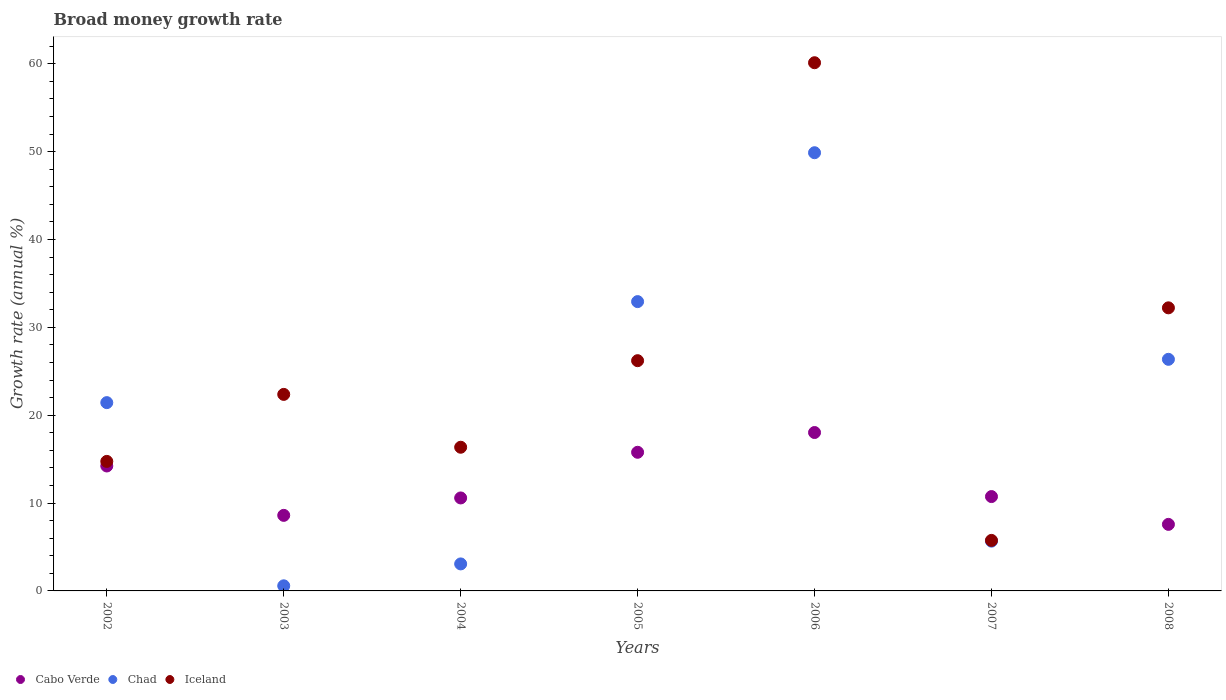What is the growth rate in Cabo Verde in 2005?
Offer a terse response. 15.78. Across all years, what is the maximum growth rate in Iceland?
Make the answer very short. 60.12. Across all years, what is the minimum growth rate in Cabo Verde?
Offer a terse response. 7.57. What is the total growth rate in Chad in the graph?
Make the answer very short. 139.92. What is the difference between the growth rate in Chad in 2003 and that in 2007?
Your response must be concise. -5.08. What is the difference between the growth rate in Iceland in 2006 and the growth rate in Chad in 2003?
Give a very brief answer. 59.54. What is the average growth rate in Iceland per year?
Give a very brief answer. 25.39. In the year 2005, what is the difference between the growth rate in Iceland and growth rate in Chad?
Your answer should be compact. -6.72. What is the ratio of the growth rate in Iceland in 2003 to that in 2006?
Your response must be concise. 0.37. What is the difference between the highest and the second highest growth rate in Iceland?
Provide a short and direct response. 27.9. What is the difference between the highest and the lowest growth rate in Iceland?
Your response must be concise. 54.37. In how many years, is the growth rate in Chad greater than the average growth rate in Chad taken over all years?
Your response must be concise. 4. Is the sum of the growth rate in Cabo Verde in 2002 and 2006 greater than the maximum growth rate in Chad across all years?
Ensure brevity in your answer.  No. Does the growth rate in Iceland monotonically increase over the years?
Offer a very short reply. No. How many years are there in the graph?
Provide a succinct answer. 7. What is the difference between two consecutive major ticks on the Y-axis?
Your answer should be very brief. 10. Are the values on the major ticks of Y-axis written in scientific E-notation?
Your response must be concise. No. Does the graph contain any zero values?
Your answer should be very brief. No. How many legend labels are there?
Give a very brief answer. 3. What is the title of the graph?
Offer a terse response. Broad money growth rate. What is the label or title of the Y-axis?
Your response must be concise. Growth rate (annual %). What is the Growth rate (annual %) in Cabo Verde in 2002?
Offer a very short reply. 14.22. What is the Growth rate (annual %) in Chad in 2002?
Your answer should be very brief. 21.43. What is the Growth rate (annual %) in Iceland in 2002?
Keep it short and to the point. 14.74. What is the Growth rate (annual %) of Cabo Verde in 2003?
Offer a terse response. 8.6. What is the Growth rate (annual %) in Chad in 2003?
Provide a succinct answer. 0.58. What is the Growth rate (annual %) in Iceland in 2003?
Make the answer very short. 22.37. What is the Growth rate (annual %) of Cabo Verde in 2004?
Keep it short and to the point. 10.58. What is the Growth rate (annual %) of Chad in 2004?
Your answer should be very brief. 3.07. What is the Growth rate (annual %) of Iceland in 2004?
Provide a succinct answer. 16.35. What is the Growth rate (annual %) in Cabo Verde in 2005?
Offer a very short reply. 15.78. What is the Growth rate (annual %) of Chad in 2005?
Offer a terse response. 32.93. What is the Growth rate (annual %) in Iceland in 2005?
Your response must be concise. 26.21. What is the Growth rate (annual %) in Cabo Verde in 2006?
Provide a short and direct response. 18.03. What is the Growth rate (annual %) in Chad in 2006?
Keep it short and to the point. 49.88. What is the Growth rate (annual %) of Iceland in 2006?
Your answer should be very brief. 60.12. What is the Growth rate (annual %) of Cabo Verde in 2007?
Offer a very short reply. 10.74. What is the Growth rate (annual %) of Chad in 2007?
Your response must be concise. 5.66. What is the Growth rate (annual %) of Iceland in 2007?
Your answer should be very brief. 5.75. What is the Growth rate (annual %) of Cabo Verde in 2008?
Provide a short and direct response. 7.57. What is the Growth rate (annual %) of Chad in 2008?
Offer a terse response. 26.36. What is the Growth rate (annual %) of Iceland in 2008?
Ensure brevity in your answer.  32.22. Across all years, what is the maximum Growth rate (annual %) of Cabo Verde?
Provide a succinct answer. 18.03. Across all years, what is the maximum Growth rate (annual %) in Chad?
Provide a succinct answer. 49.88. Across all years, what is the maximum Growth rate (annual %) of Iceland?
Offer a very short reply. 60.12. Across all years, what is the minimum Growth rate (annual %) in Cabo Verde?
Provide a succinct answer. 7.57. Across all years, what is the minimum Growth rate (annual %) in Chad?
Your answer should be compact. 0.58. Across all years, what is the minimum Growth rate (annual %) of Iceland?
Keep it short and to the point. 5.75. What is the total Growth rate (annual %) in Cabo Verde in the graph?
Offer a very short reply. 85.53. What is the total Growth rate (annual %) in Chad in the graph?
Your answer should be very brief. 139.92. What is the total Growth rate (annual %) of Iceland in the graph?
Make the answer very short. 177.76. What is the difference between the Growth rate (annual %) in Cabo Verde in 2002 and that in 2003?
Offer a terse response. 5.62. What is the difference between the Growth rate (annual %) of Chad in 2002 and that in 2003?
Give a very brief answer. 20.85. What is the difference between the Growth rate (annual %) of Iceland in 2002 and that in 2003?
Keep it short and to the point. -7.63. What is the difference between the Growth rate (annual %) in Cabo Verde in 2002 and that in 2004?
Give a very brief answer. 3.64. What is the difference between the Growth rate (annual %) of Chad in 2002 and that in 2004?
Make the answer very short. 18.36. What is the difference between the Growth rate (annual %) of Iceland in 2002 and that in 2004?
Make the answer very short. -1.61. What is the difference between the Growth rate (annual %) of Cabo Verde in 2002 and that in 2005?
Provide a short and direct response. -1.56. What is the difference between the Growth rate (annual %) in Chad in 2002 and that in 2005?
Your answer should be compact. -11.5. What is the difference between the Growth rate (annual %) of Iceland in 2002 and that in 2005?
Your response must be concise. -11.46. What is the difference between the Growth rate (annual %) in Cabo Verde in 2002 and that in 2006?
Provide a short and direct response. -3.81. What is the difference between the Growth rate (annual %) of Chad in 2002 and that in 2006?
Offer a terse response. -28.44. What is the difference between the Growth rate (annual %) of Iceland in 2002 and that in 2006?
Your answer should be very brief. -45.38. What is the difference between the Growth rate (annual %) of Cabo Verde in 2002 and that in 2007?
Keep it short and to the point. 3.48. What is the difference between the Growth rate (annual %) in Chad in 2002 and that in 2007?
Make the answer very short. 15.77. What is the difference between the Growth rate (annual %) of Iceland in 2002 and that in 2007?
Keep it short and to the point. 8.99. What is the difference between the Growth rate (annual %) in Cabo Verde in 2002 and that in 2008?
Offer a very short reply. 6.65. What is the difference between the Growth rate (annual %) of Chad in 2002 and that in 2008?
Offer a terse response. -4.93. What is the difference between the Growth rate (annual %) in Iceland in 2002 and that in 2008?
Ensure brevity in your answer.  -17.48. What is the difference between the Growth rate (annual %) in Cabo Verde in 2003 and that in 2004?
Offer a very short reply. -1.98. What is the difference between the Growth rate (annual %) in Chad in 2003 and that in 2004?
Provide a short and direct response. -2.49. What is the difference between the Growth rate (annual %) of Iceland in 2003 and that in 2004?
Provide a succinct answer. 6.01. What is the difference between the Growth rate (annual %) in Cabo Verde in 2003 and that in 2005?
Provide a succinct answer. -7.18. What is the difference between the Growth rate (annual %) in Chad in 2003 and that in 2005?
Keep it short and to the point. -32.35. What is the difference between the Growth rate (annual %) in Iceland in 2003 and that in 2005?
Keep it short and to the point. -3.84. What is the difference between the Growth rate (annual %) of Cabo Verde in 2003 and that in 2006?
Offer a very short reply. -9.43. What is the difference between the Growth rate (annual %) in Chad in 2003 and that in 2006?
Make the answer very short. -49.29. What is the difference between the Growth rate (annual %) of Iceland in 2003 and that in 2006?
Offer a terse response. -37.75. What is the difference between the Growth rate (annual %) in Cabo Verde in 2003 and that in 2007?
Make the answer very short. -2.14. What is the difference between the Growth rate (annual %) in Chad in 2003 and that in 2007?
Offer a terse response. -5.08. What is the difference between the Growth rate (annual %) of Iceland in 2003 and that in 2007?
Give a very brief answer. 16.62. What is the difference between the Growth rate (annual %) in Cabo Verde in 2003 and that in 2008?
Keep it short and to the point. 1.03. What is the difference between the Growth rate (annual %) of Chad in 2003 and that in 2008?
Provide a succinct answer. -25.78. What is the difference between the Growth rate (annual %) in Iceland in 2003 and that in 2008?
Keep it short and to the point. -9.85. What is the difference between the Growth rate (annual %) of Cabo Verde in 2004 and that in 2005?
Keep it short and to the point. -5.2. What is the difference between the Growth rate (annual %) in Chad in 2004 and that in 2005?
Ensure brevity in your answer.  -29.86. What is the difference between the Growth rate (annual %) in Iceland in 2004 and that in 2005?
Give a very brief answer. -9.85. What is the difference between the Growth rate (annual %) of Cabo Verde in 2004 and that in 2006?
Give a very brief answer. -7.45. What is the difference between the Growth rate (annual %) in Chad in 2004 and that in 2006?
Offer a terse response. -46.8. What is the difference between the Growth rate (annual %) of Iceland in 2004 and that in 2006?
Your answer should be very brief. -43.77. What is the difference between the Growth rate (annual %) of Cabo Verde in 2004 and that in 2007?
Offer a terse response. -0.16. What is the difference between the Growth rate (annual %) in Chad in 2004 and that in 2007?
Ensure brevity in your answer.  -2.59. What is the difference between the Growth rate (annual %) in Iceland in 2004 and that in 2007?
Your answer should be compact. 10.6. What is the difference between the Growth rate (annual %) of Cabo Verde in 2004 and that in 2008?
Provide a succinct answer. 3.01. What is the difference between the Growth rate (annual %) in Chad in 2004 and that in 2008?
Your response must be concise. -23.29. What is the difference between the Growth rate (annual %) in Iceland in 2004 and that in 2008?
Provide a succinct answer. -15.87. What is the difference between the Growth rate (annual %) of Cabo Verde in 2005 and that in 2006?
Provide a succinct answer. -2.25. What is the difference between the Growth rate (annual %) of Chad in 2005 and that in 2006?
Offer a very short reply. -16.95. What is the difference between the Growth rate (annual %) in Iceland in 2005 and that in 2006?
Your response must be concise. -33.91. What is the difference between the Growth rate (annual %) in Cabo Verde in 2005 and that in 2007?
Offer a very short reply. 5.04. What is the difference between the Growth rate (annual %) of Chad in 2005 and that in 2007?
Make the answer very short. 27.26. What is the difference between the Growth rate (annual %) of Iceland in 2005 and that in 2007?
Your answer should be very brief. 20.46. What is the difference between the Growth rate (annual %) in Cabo Verde in 2005 and that in 2008?
Provide a short and direct response. 8.21. What is the difference between the Growth rate (annual %) of Chad in 2005 and that in 2008?
Provide a short and direct response. 6.57. What is the difference between the Growth rate (annual %) in Iceland in 2005 and that in 2008?
Offer a very short reply. -6.01. What is the difference between the Growth rate (annual %) in Cabo Verde in 2006 and that in 2007?
Give a very brief answer. 7.29. What is the difference between the Growth rate (annual %) of Chad in 2006 and that in 2007?
Ensure brevity in your answer.  44.21. What is the difference between the Growth rate (annual %) in Iceland in 2006 and that in 2007?
Your response must be concise. 54.37. What is the difference between the Growth rate (annual %) of Cabo Verde in 2006 and that in 2008?
Provide a succinct answer. 10.45. What is the difference between the Growth rate (annual %) in Chad in 2006 and that in 2008?
Make the answer very short. 23.51. What is the difference between the Growth rate (annual %) of Iceland in 2006 and that in 2008?
Your answer should be compact. 27.9. What is the difference between the Growth rate (annual %) of Cabo Verde in 2007 and that in 2008?
Provide a short and direct response. 3.16. What is the difference between the Growth rate (annual %) in Chad in 2007 and that in 2008?
Make the answer very short. -20.7. What is the difference between the Growth rate (annual %) in Iceland in 2007 and that in 2008?
Give a very brief answer. -26.47. What is the difference between the Growth rate (annual %) in Cabo Verde in 2002 and the Growth rate (annual %) in Chad in 2003?
Provide a succinct answer. 13.64. What is the difference between the Growth rate (annual %) of Cabo Verde in 2002 and the Growth rate (annual %) of Iceland in 2003?
Offer a terse response. -8.15. What is the difference between the Growth rate (annual %) of Chad in 2002 and the Growth rate (annual %) of Iceland in 2003?
Your answer should be compact. -0.94. What is the difference between the Growth rate (annual %) in Cabo Verde in 2002 and the Growth rate (annual %) in Chad in 2004?
Your answer should be compact. 11.15. What is the difference between the Growth rate (annual %) in Cabo Verde in 2002 and the Growth rate (annual %) in Iceland in 2004?
Your response must be concise. -2.13. What is the difference between the Growth rate (annual %) of Chad in 2002 and the Growth rate (annual %) of Iceland in 2004?
Offer a very short reply. 5.08. What is the difference between the Growth rate (annual %) of Cabo Verde in 2002 and the Growth rate (annual %) of Chad in 2005?
Provide a short and direct response. -18.71. What is the difference between the Growth rate (annual %) in Cabo Verde in 2002 and the Growth rate (annual %) in Iceland in 2005?
Give a very brief answer. -11.99. What is the difference between the Growth rate (annual %) of Chad in 2002 and the Growth rate (annual %) of Iceland in 2005?
Offer a very short reply. -4.77. What is the difference between the Growth rate (annual %) of Cabo Verde in 2002 and the Growth rate (annual %) of Chad in 2006?
Your response must be concise. -35.65. What is the difference between the Growth rate (annual %) in Cabo Verde in 2002 and the Growth rate (annual %) in Iceland in 2006?
Ensure brevity in your answer.  -45.9. What is the difference between the Growth rate (annual %) of Chad in 2002 and the Growth rate (annual %) of Iceland in 2006?
Offer a terse response. -38.69. What is the difference between the Growth rate (annual %) in Cabo Verde in 2002 and the Growth rate (annual %) in Chad in 2007?
Provide a succinct answer. 8.56. What is the difference between the Growth rate (annual %) in Cabo Verde in 2002 and the Growth rate (annual %) in Iceland in 2007?
Offer a terse response. 8.47. What is the difference between the Growth rate (annual %) of Chad in 2002 and the Growth rate (annual %) of Iceland in 2007?
Your response must be concise. 15.68. What is the difference between the Growth rate (annual %) in Cabo Verde in 2002 and the Growth rate (annual %) in Chad in 2008?
Offer a very short reply. -12.14. What is the difference between the Growth rate (annual %) in Cabo Verde in 2002 and the Growth rate (annual %) in Iceland in 2008?
Offer a terse response. -18. What is the difference between the Growth rate (annual %) of Chad in 2002 and the Growth rate (annual %) of Iceland in 2008?
Your answer should be compact. -10.79. What is the difference between the Growth rate (annual %) of Cabo Verde in 2003 and the Growth rate (annual %) of Chad in 2004?
Ensure brevity in your answer.  5.53. What is the difference between the Growth rate (annual %) of Cabo Verde in 2003 and the Growth rate (annual %) of Iceland in 2004?
Your answer should be very brief. -7.75. What is the difference between the Growth rate (annual %) of Chad in 2003 and the Growth rate (annual %) of Iceland in 2004?
Make the answer very short. -15.77. What is the difference between the Growth rate (annual %) of Cabo Verde in 2003 and the Growth rate (annual %) of Chad in 2005?
Ensure brevity in your answer.  -24.33. What is the difference between the Growth rate (annual %) of Cabo Verde in 2003 and the Growth rate (annual %) of Iceland in 2005?
Keep it short and to the point. -17.61. What is the difference between the Growth rate (annual %) in Chad in 2003 and the Growth rate (annual %) in Iceland in 2005?
Make the answer very short. -25.63. What is the difference between the Growth rate (annual %) of Cabo Verde in 2003 and the Growth rate (annual %) of Chad in 2006?
Give a very brief answer. -41.28. What is the difference between the Growth rate (annual %) in Cabo Verde in 2003 and the Growth rate (annual %) in Iceland in 2006?
Make the answer very short. -51.52. What is the difference between the Growth rate (annual %) of Chad in 2003 and the Growth rate (annual %) of Iceland in 2006?
Offer a very short reply. -59.54. What is the difference between the Growth rate (annual %) in Cabo Verde in 2003 and the Growth rate (annual %) in Chad in 2007?
Provide a short and direct response. 2.94. What is the difference between the Growth rate (annual %) of Cabo Verde in 2003 and the Growth rate (annual %) of Iceland in 2007?
Give a very brief answer. 2.85. What is the difference between the Growth rate (annual %) in Chad in 2003 and the Growth rate (annual %) in Iceland in 2007?
Give a very brief answer. -5.17. What is the difference between the Growth rate (annual %) in Cabo Verde in 2003 and the Growth rate (annual %) in Chad in 2008?
Ensure brevity in your answer.  -17.76. What is the difference between the Growth rate (annual %) of Cabo Verde in 2003 and the Growth rate (annual %) of Iceland in 2008?
Your answer should be very brief. -23.62. What is the difference between the Growth rate (annual %) in Chad in 2003 and the Growth rate (annual %) in Iceland in 2008?
Your response must be concise. -31.64. What is the difference between the Growth rate (annual %) in Cabo Verde in 2004 and the Growth rate (annual %) in Chad in 2005?
Ensure brevity in your answer.  -22.35. What is the difference between the Growth rate (annual %) of Cabo Verde in 2004 and the Growth rate (annual %) of Iceland in 2005?
Your answer should be compact. -15.62. What is the difference between the Growth rate (annual %) of Chad in 2004 and the Growth rate (annual %) of Iceland in 2005?
Provide a short and direct response. -23.13. What is the difference between the Growth rate (annual %) in Cabo Verde in 2004 and the Growth rate (annual %) in Chad in 2006?
Offer a very short reply. -39.29. What is the difference between the Growth rate (annual %) of Cabo Verde in 2004 and the Growth rate (annual %) of Iceland in 2006?
Provide a succinct answer. -49.54. What is the difference between the Growth rate (annual %) in Chad in 2004 and the Growth rate (annual %) in Iceland in 2006?
Your answer should be very brief. -57.05. What is the difference between the Growth rate (annual %) in Cabo Verde in 2004 and the Growth rate (annual %) in Chad in 2007?
Provide a short and direct response. 4.92. What is the difference between the Growth rate (annual %) of Cabo Verde in 2004 and the Growth rate (annual %) of Iceland in 2007?
Offer a very short reply. 4.83. What is the difference between the Growth rate (annual %) in Chad in 2004 and the Growth rate (annual %) in Iceland in 2007?
Offer a terse response. -2.68. What is the difference between the Growth rate (annual %) of Cabo Verde in 2004 and the Growth rate (annual %) of Chad in 2008?
Provide a succinct answer. -15.78. What is the difference between the Growth rate (annual %) of Cabo Verde in 2004 and the Growth rate (annual %) of Iceland in 2008?
Your answer should be very brief. -21.64. What is the difference between the Growth rate (annual %) of Chad in 2004 and the Growth rate (annual %) of Iceland in 2008?
Offer a very short reply. -29.15. What is the difference between the Growth rate (annual %) of Cabo Verde in 2005 and the Growth rate (annual %) of Chad in 2006?
Keep it short and to the point. -34.1. What is the difference between the Growth rate (annual %) in Cabo Verde in 2005 and the Growth rate (annual %) in Iceland in 2006?
Your answer should be very brief. -44.34. What is the difference between the Growth rate (annual %) of Chad in 2005 and the Growth rate (annual %) of Iceland in 2006?
Give a very brief answer. -27.19. What is the difference between the Growth rate (annual %) in Cabo Verde in 2005 and the Growth rate (annual %) in Chad in 2007?
Your response must be concise. 10.12. What is the difference between the Growth rate (annual %) in Cabo Verde in 2005 and the Growth rate (annual %) in Iceland in 2007?
Offer a very short reply. 10.03. What is the difference between the Growth rate (annual %) of Chad in 2005 and the Growth rate (annual %) of Iceland in 2007?
Your response must be concise. 27.18. What is the difference between the Growth rate (annual %) of Cabo Verde in 2005 and the Growth rate (annual %) of Chad in 2008?
Provide a short and direct response. -10.58. What is the difference between the Growth rate (annual %) in Cabo Verde in 2005 and the Growth rate (annual %) in Iceland in 2008?
Give a very brief answer. -16.44. What is the difference between the Growth rate (annual %) of Chad in 2005 and the Growth rate (annual %) of Iceland in 2008?
Give a very brief answer. 0.71. What is the difference between the Growth rate (annual %) of Cabo Verde in 2006 and the Growth rate (annual %) of Chad in 2007?
Provide a succinct answer. 12.36. What is the difference between the Growth rate (annual %) in Cabo Verde in 2006 and the Growth rate (annual %) in Iceland in 2007?
Offer a terse response. 12.28. What is the difference between the Growth rate (annual %) of Chad in 2006 and the Growth rate (annual %) of Iceland in 2007?
Provide a succinct answer. 44.13. What is the difference between the Growth rate (annual %) of Cabo Verde in 2006 and the Growth rate (annual %) of Chad in 2008?
Give a very brief answer. -8.33. What is the difference between the Growth rate (annual %) in Cabo Verde in 2006 and the Growth rate (annual %) in Iceland in 2008?
Your answer should be compact. -14.19. What is the difference between the Growth rate (annual %) of Chad in 2006 and the Growth rate (annual %) of Iceland in 2008?
Your answer should be compact. 17.66. What is the difference between the Growth rate (annual %) of Cabo Verde in 2007 and the Growth rate (annual %) of Chad in 2008?
Give a very brief answer. -15.62. What is the difference between the Growth rate (annual %) in Cabo Verde in 2007 and the Growth rate (annual %) in Iceland in 2008?
Provide a short and direct response. -21.48. What is the difference between the Growth rate (annual %) of Chad in 2007 and the Growth rate (annual %) of Iceland in 2008?
Provide a succinct answer. -26.56. What is the average Growth rate (annual %) of Cabo Verde per year?
Your answer should be compact. 12.22. What is the average Growth rate (annual %) of Chad per year?
Your answer should be compact. 19.99. What is the average Growth rate (annual %) in Iceland per year?
Your answer should be compact. 25.39. In the year 2002, what is the difference between the Growth rate (annual %) in Cabo Verde and Growth rate (annual %) in Chad?
Give a very brief answer. -7.21. In the year 2002, what is the difference between the Growth rate (annual %) of Cabo Verde and Growth rate (annual %) of Iceland?
Offer a very short reply. -0.52. In the year 2002, what is the difference between the Growth rate (annual %) of Chad and Growth rate (annual %) of Iceland?
Your answer should be compact. 6.69. In the year 2003, what is the difference between the Growth rate (annual %) of Cabo Verde and Growth rate (annual %) of Chad?
Make the answer very short. 8.02. In the year 2003, what is the difference between the Growth rate (annual %) in Cabo Verde and Growth rate (annual %) in Iceland?
Make the answer very short. -13.77. In the year 2003, what is the difference between the Growth rate (annual %) in Chad and Growth rate (annual %) in Iceland?
Offer a very short reply. -21.79. In the year 2004, what is the difference between the Growth rate (annual %) of Cabo Verde and Growth rate (annual %) of Chad?
Offer a very short reply. 7.51. In the year 2004, what is the difference between the Growth rate (annual %) of Cabo Verde and Growth rate (annual %) of Iceland?
Provide a succinct answer. -5.77. In the year 2004, what is the difference between the Growth rate (annual %) of Chad and Growth rate (annual %) of Iceland?
Offer a very short reply. -13.28. In the year 2005, what is the difference between the Growth rate (annual %) in Cabo Verde and Growth rate (annual %) in Chad?
Your answer should be very brief. -17.15. In the year 2005, what is the difference between the Growth rate (annual %) of Cabo Verde and Growth rate (annual %) of Iceland?
Provide a succinct answer. -10.43. In the year 2005, what is the difference between the Growth rate (annual %) in Chad and Growth rate (annual %) in Iceland?
Make the answer very short. 6.72. In the year 2006, what is the difference between the Growth rate (annual %) in Cabo Verde and Growth rate (annual %) in Chad?
Keep it short and to the point. -31.85. In the year 2006, what is the difference between the Growth rate (annual %) in Cabo Verde and Growth rate (annual %) in Iceland?
Keep it short and to the point. -42.09. In the year 2006, what is the difference between the Growth rate (annual %) in Chad and Growth rate (annual %) in Iceland?
Offer a terse response. -10.24. In the year 2007, what is the difference between the Growth rate (annual %) in Cabo Verde and Growth rate (annual %) in Chad?
Offer a very short reply. 5.07. In the year 2007, what is the difference between the Growth rate (annual %) of Cabo Verde and Growth rate (annual %) of Iceland?
Provide a short and direct response. 4.99. In the year 2007, what is the difference between the Growth rate (annual %) in Chad and Growth rate (annual %) in Iceland?
Make the answer very short. -0.09. In the year 2008, what is the difference between the Growth rate (annual %) of Cabo Verde and Growth rate (annual %) of Chad?
Give a very brief answer. -18.79. In the year 2008, what is the difference between the Growth rate (annual %) in Cabo Verde and Growth rate (annual %) in Iceland?
Make the answer very short. -24.65. In the year 2008, what is the difference between the Growth rate (annual %) of Chad and Growth rate (annual %) of Iceland?
Make the answer very short. -5.86. What is the ratio of the Growth rate (annual %) of Cabo Verde in 2002 to that in 2003?
Make the answer very short. 1.65. What is the ratio of the Growth rate (annual %) of Chad in 2002 to that in 2003?
Ensure brevity in your answer.  36.88. What is the ratio of the Growth rate (annual %) of Iceland in 2002 to that in 2003?
Give a very brief answer. 0.66. What is the ratio of the Growth rate (annual %) of Cabo Verde in 2002 to that in 2004?
Your answer should be very brief. 1.34. What is the ratio of the Growth rate (annual %) in Chad in 2002 to that in 2004?
Ensure brevity in your answer.  6.97. What is the ratio of the Growth rate (annual %) in Iceland in 2002 to that in 2004?
Offer a very short reply. 0.9. What is the ratio of the Growth rate (annual %) of Cabo Verde in 2002 to that in 2005?
Your answer should be very brief. 0.9. What is the ratio of the Growth rate (annual %) of Chad in 2002 to that in 2005?
Make the answer very short. 0.65. What is the ratio of the Growth rate (annual %) in Iceland in 2002 to that in 2005?
Your response must be concise. 0.56. What is the ratio of the Growth rate (annual %) in Cabo Verde in 2002 to that in 2006?
Make the answer very short. 0.79. What is the ratio of the Growth rate (annual %) in Chad in 2002 to that in 2006?
Offer a very short reply. 0.43. What is the ratio of the Growth rate (annual %) of Iceland in 2002 to that in 2006?
Keep it short and to the point. 0.25. What is the ratio of the Growth rate (annual %) in Cabo Verde in 2002 to that in 2007?
Provide a short and direct response. 1.32. What is the ratio of the Growth rate (annual %) of Chad in 2002 to that in 2007?
Make the answer very short. 3.78. What is the ratio of the Growth rate (annual %) in Iceland in 2002 to that in 2007?
Ensure brevity in your answer.  2.56. What is the ratio of the Growth rate (annual %) in Cabo Verde in 2002 to that in 2008?
Provide a short and direct response. 1.88. What is the ratio of the Growth rate (annual %) of Chad in 2002 to that in 2008?
Your answer should be compact. 0.81. What is the ratio of the Growth rate (annual %) in Iceland in 2002 to that in 2008?
Offer a terse response. 0.46. What is the ratio of the Growth rate (annual %) of Cabo Verde in 2003 to that in 2004?
Offer a terse response. 0.81. What is the ratio of the Growth rate (annual %) of Chad in 2003 to that in 2004?
Offer a very short reply. 0.19. What is the ratio of the Growth rate (annual %) in Iceland in 2003 to that in 2004?
Offer a terse response. 1.37. What is the ratio of the Growth rate (annual %) in Cabo Verde in 2003 to that in 2005?
Give a very brief answer. 0.55. What is the ratio of the Growth rate (annual %) of Chad in 2003 to that in 2005?
Ensure brevity in your answer.  0.02. What is the ratio of the Growth rate (annual %) of Iceland in 2003 to that in 2005?
Your answer should be compact. 0.85. What is the ratio of the Growth rate (annual %) of Cabo Verde in 2003 to that in 2006?
Offer a terse response. 0.48. What is the ratio of the Growth rate (annual %) of Chad in 2003 to that in 2006?
Make the answer very short. 0.01. What is the ratio of the Growth rate (annual %) in Iceland in 2003 to that in 2006?
Your response must be concise. 0.37. What is the ratio of the Growth rate (annual %) of Cabo Verde in 2003 to that in 2007?
Provide a short and direct response. 0.8. What is the ratio of the Growth rate (annual %) in Chad in 2003 to that in 2007?
Provide a succinct answer. 0.1. What is the ratio of the Growth rate (annual %) of Iceland in 2003 to that in 2007?
Offer a terse response. 3.89. What is the ratio of the Growth rate (annual %) in Cabo Verde in 2003 to that in 2008?
Offer a terse response. 1.14. What is the ratio of the Growth rate (annual %) in Chad in 2003 to that in 2008?
Offer a terse response. 0.02. What is the ratio of the Growth rate (annual %) in Iceland in 2003 to that in 2008?
Your answer should be compact. 0.69. What is the ratio of the Growth rate (annual %) of Cabo Verde in 2004 to that in 2005?
Give a very brief answer. 0.67. What is the ratio of the Growth rate (annual %) in Chad in 2004 to that in 2005?
Your response must be concise. 0.09. What is the ratio of the Growth rate (annual %) of Iceland in 2004 to that in 2005?
Offer a very short reply. 0.62. What is the ratio of the Growth rate (annual %) of Cabo Verde in 2004 to that in 2006?
Ensure brevity in your answer.  0.59. What is the ratio of the Growth rate (annual %) of Chad in 2004 to that in 2006?
Offer a very short reply. 0.06. What is the ratio of the Growth rate (annual %) of Iceland in 2004 to that in 2006?
Ensure brevity in your answer.  0.27. What is the ratio of the Growth rate (annual %) in Cabo Verde in 2004 to that in 2007?
Keep it short and to the point. 0.99. What is the ratio of the Growth rate (annual %) of Chad in 2004 to that in 2007?
Offer a very short reply. 0.54. What is the ratio of the Growth rate (annual %) of Iceland in 2004 to that in 2007?
Your answer should be compact. 2.84. What is the ratio of the Growth rate (annual %) in Cabo Verde in 2004 to that in 2008?
Offer a very short reply. 1.4. What is the ratio of the Growth rate (annual %) in Chad in 2004 to that in 2008?
Offer a terse response. 0.12. What is the ratio of the Growth rate (annual %) in Iceland in 2004 to that in 2008?
Give a very brief answer. 0.51. What is the ratio of the Growth rate (annual %) in Cabo Verde in 2005 to that in 2006?
Provide a succinct answer. 0.88. What is the ratio of the Growth rate (annual %) in Chad in 2005 to that in 2006?
Ensure brevity in your answer.  0.66. What is the ratio of the Growth rate (annual %) of Iceland in 2005 to that in 2006?
Provide a short and direct response. 0.44. What is the ratio of the Growth rate (annual %) of Cabo Verde in 2005 to that in 2007?
Keep it short and to the point. 1.47. What is the ratio of the Growth rate (annual %) in Chad in 2005 to that in 2007?
Offer a very short reply. 5.81. What is the ratio of the Growth rate (annual %) in Iceland in 2005 to that in 2007?
Your answer should be compact. 4.56. What is the ratio of the Growth rate (annual %) of Cabo Verde in 2005 to that in 2008?
Offer a very short reply. 2.08. What is the ratio of the Growth rate (annual %) of Chad in 2005 to that in 2008?
Your response must be concise. 1.25. What is the ratio of the Growth rate (annual %) of Iceland in 2005 to that in 2008?
Your answer should be compact. 0.81. What is the ratio of the Growth rate (annual %) in Cabo Verde in 2006 to that in 2007?
Ensure brevity in your answer.  1.68. What is the ratio of the Growth rate (annual %) in Chad in 2006 to that in 2007?
Provide a short and direct response. 8.8. What is the ratio of the Growth rate (annual %) in Iceland in 2006 to that in 2007?
Your response must be concise. 10.45. What is the ratio of the Growth rate (annual %) of Cabo Verde in 2006 to that in 2008?
Offer a terse response. 2.38. What is the ratio of the Growth rate (annual %) of Chad in 2006 to that in 2008?
Give a very brief answer. 1.89. What is the ratio of the Growth rate (annual %) of Iceland in 2006 to that in 2008?
Provide a succinct answer. 1.87. What is the ratio of the Growth rate (annual %) of Cabo Verde in 2007 to that in 2008?
Provide a succinct answer. 1.42. What is the ratio of the Growth rate (annual %) in Chad in 2007 to that in 2008?
Offer a terse response. 0.21. What is the ratio of the Growth rate (annual %) in Iceland in 2007 to that in 2008?
Your response must be concise. 0.18. What is the difference between the highest and the second highest Growth rate (annual %) in Cabo Verde?
Your response must be concise. 2.25. What is the difference between the highest and the second highest Growth rate (annual %) of Chad?
Keep it short and to the point. 16.95. What is the difference between the highest and the second highest Growth rate (annual %) of Iceland?
Provide a short and direct response. 27.9. What is the difference between the highest and the lowest Growth rate (annual %) in Cabo Verde?
Give a very brief answer. 10.45. What is the difference between the highest and the lowest Growth rate (annual %) in Chad?
Provide a succinct answer. 49.29. What is the difference between the highest and the lowest Growth rate (annual %) in Iceland?
Give a very brief answer. 54.37. 